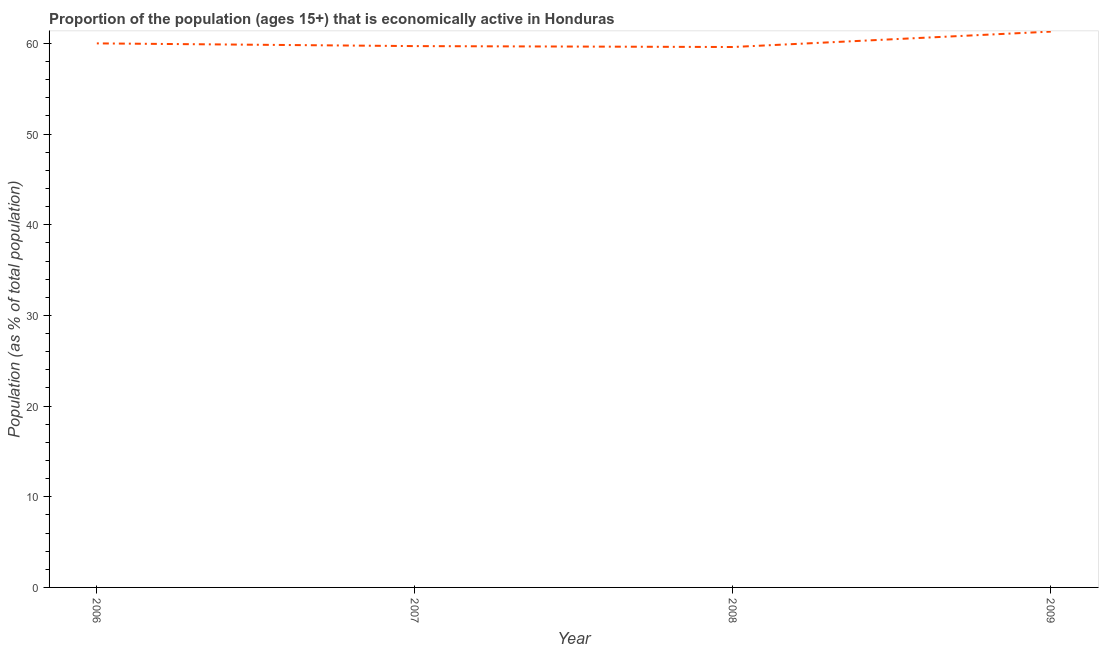What is the percentage of economically active population in 2007?
Make the answer very short. 59.7. Across all years, what is the maximum percentage of economically active population?
Your answer should be very brief. 61.3. Across all years, what is the minimum percentage of economically active population?
Keep it short and to the point. 59.6. In which year was the percentage of economically active population maximum?
Your response must be concise. 2009. What is the sum of the percentage of economically active population?
Your response must be concise. 240.6. What is the difference between the percentage of economically active population in 2006 and 2008?
Offer a very short reply. 0.4. What is the average percentage of economically active population per year?
Provide a short and direct response. 60.15. What is the median percentage of economically active population?
Offer a very short reply. 59.85. In how many years, is the percentage of economically active population greater than 44 %?
Offer a very short reply. 4. Do a majority of the years between 2006 and 2008 (inclusive) have percentage of economically active population greater than 12 %?
Provide a succinct answer. Yes. What is the ratio of the percentage of economically active population in 2007 to that in 2009?
Your response must be concise. 0.97. What is the difference between the highest and the second highest percentage of economically active population?
Your answer should be very brief. 1.3. What is the difference between the highest and the lowest percentage of economically active population?
Provide a succinct answer. 1.7. In how many years, is the percentage of economically active population greater than the average percentage of economically active population taken over all years?
Ensure brevity in your answer.  1. Does the percentage of economically active population monotonically increase over the years?
Your answer should be very brief. No. What is the title of the graph?
Ensure brevity in your answer.  Proportion of the population (ages 15+) that is economically active in Honduras. What is the label or title of the X-axis?
Offer a very short reply. Year. What is the label or title of the Y-axis?
Offer a terse response. Population (as % of total population). What is the Population (as % of total population) in 2006?
Your answer should be very brief. 60. What is the Population (as % of total population) of 2007?
Your response must be concise. 59.7. What is the Population (as % of total population) of 2008?
Make the answer very short. 59.6. What is the Population (as % of total population) in 2009?
Your response must be concise. 61.3. What is the difference between the Population (as % of total population) in 2006 and 2007?
Your response must be concise. 0.3. What is the difference between the Population (as % of total population) in 2006 and 2008?
Provide a succinct answer. 0.4. What is the difference between the Population (as % of total population) in 2007 and 2008?
Keep it short and to the point. 0.1. What is the difference between the Population (as % of total population) in 2007 and 2009?
Give a very brief answer. -1.6. What is the ratio of the Population (as % of total population) in 2006 to that in 2007?
Your answer should be compact. 1. What is the ratio of the Population (as % of total population) in 2008 to that in 2009?
Keep it short and to the point. 0.97. 